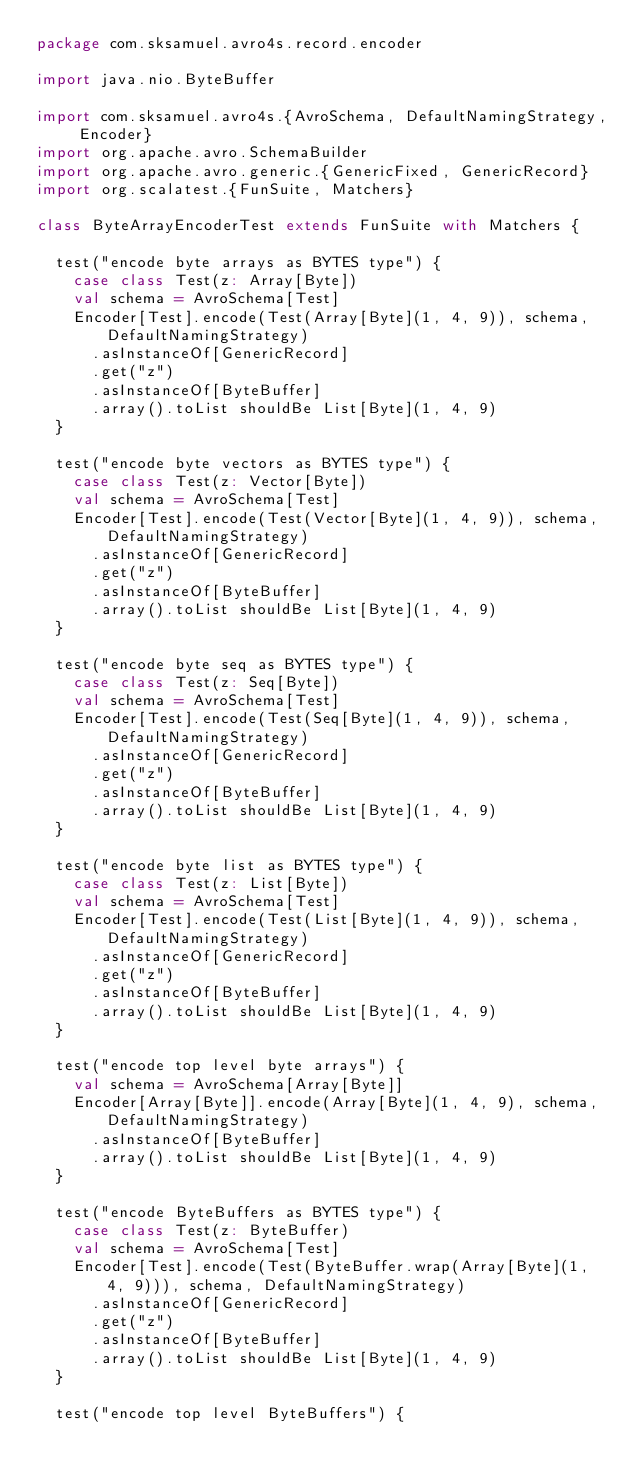<code> <loc_0><loc_0><loc_500><loc_500><_Scala_>package com.sksamuel.avro4s.record.encoder

import java.nio.ByteBuffer

import com.sksamuel.avro4s.{AvroSchema, DefaultNamingStrategy, Encoder}
import org.apache.avro.SchemaBuilder
import org.apache.avro.generic.{GenericFixed, GenericRecord}
import org.scalatest.{FunSuite, Matchers}

class ByteArrayEncoderTest extends FunSuite with Matchers {

  test("encode byte arrays as BYTES type") {
    case class Test(z: Array[Byte])
    val schema = AvroSchema[Test]
    Encoder[Test].encode(Test(Array[Byte](1, 4, 9)), schema, DefaultNamingStrategy)
      .asInstanceOf[GenericRecord]
      .get("z")
      .asInstanceOf[ByteBuffer]
      .array().toList shouldBe List[Byte](1, 4, 9)
  }

  test("encode byte vectors as BYTES type") {
    case class Test(z: Vector[Byte])
    val schema = AvroSchema[Test]
    Encoder[Test].encode(Test(Vector[Byte](1, 4, 9)), schema, DefaultNamingStrategy)
      .asInstanceOf[GenericRecord]
      .get("z")
      .asInstanceOf[ByteBuffer]
      .array().toList shouldBe List[Byte](1, 4, 9)
  }

  test("encode byte seq as BYTES type") {
    case class Test(z: Seq[Byte])
    val schema = AvroSchema[Test]
    Encoder[Test].encode(Test(Seq[Byte](1, 4, 9)), schema, DefaultNamingStrategy)
      .asInstanceOf[GenericRecord]
      .get("z")
      .asInstanceOf[ByteBuffer]
      .array().toList shouldBe List[Byte](1, 4, 9)
  }

  test("encode byte list as BYTES type") {
    case class Test(z: List[Byte])
    val schema = AvroSchema[Test]
    Encoder[Test].encode(Test(List[Byte](1, 4, 9)), schema, DefaultNamingStrategy)
      .asInstanceOf[GenericRecord]
      .get("z")
      .asInstanceOf[ByteBuffer]
      .array().toList shouldBe List[Byte](1, 4, 9)
  }

  test("encode top level byte arrays") {
    val schema = AvroSchema[Array[Byte]]
    Encoder[Array[Byte]].encode(Array[Byte](1, 4, 9), schema, DefaultNamingStrategy)
      .asInstanceOf[ByteBuffer]
      .array().toList shouldBe List[Byte](1, 4, 9)
  }

  test("encode ByteBuffers as BYTES type") {
    case class Test(z: ByteBuffer)
    val schema = AvroSchema[Test]
    Encoder[Test].encode(Test(ByteBuffer.wrap(Array[Byte](1, 4, 9))), schema, DefaultNamingStrategy)
      .asInstanceOf[GenericRecord]
      .get("z")
      .asInstanceOf[ByteBuffer]
      .array().toList shouldBe List[Byte](1, 4, 9)
  }

  test("encode top level ByteBuffers") {</code> 